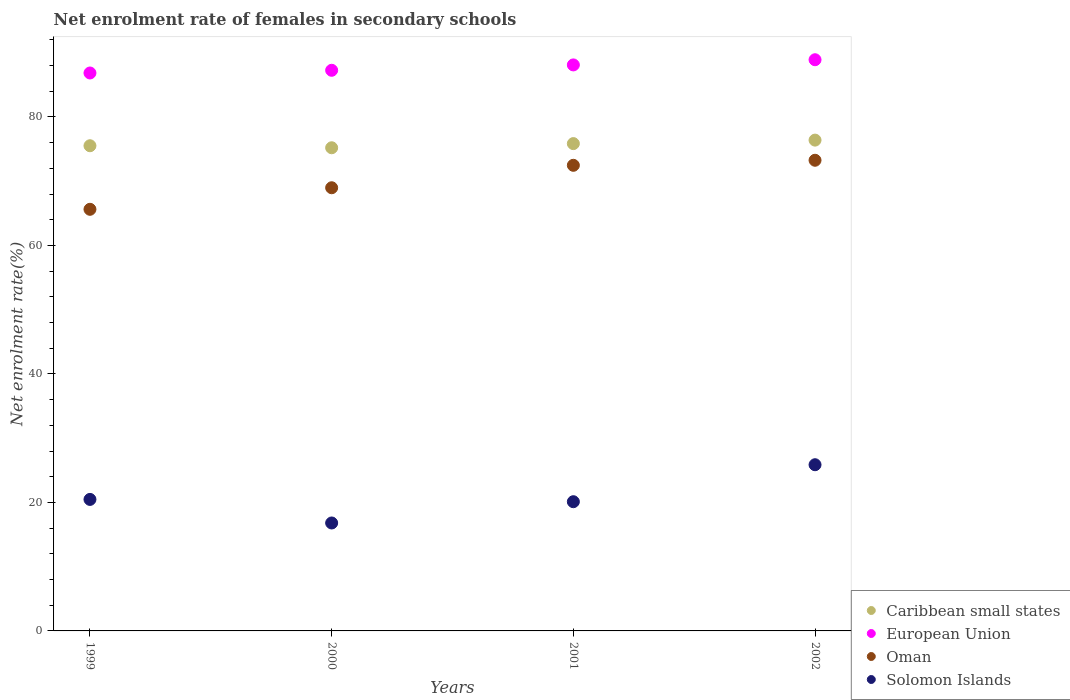How many different coloured dotlines are there?
Your response must be concise. 4. Is the number of dotlines equal to the number of legend labels?
Make the answer very short. Yes. What is the net enrolment rate of females in secondary schools in Oman in 2000?
Your response must be concise. 68.98. Across all years, what is the maximum net enrolment rate of females in secondary schools in European Union?
Make the answer very short. 88.91. Across all years, what is the minimum net enrolment rate of females in secondary schools in European Union?
Make the answer very short. 86.85. In which year was the net enrolment rate of females in secondary schools in Solomon Islands maximum?
Give a very brief answer. 2002. What is the total net enrolment rate of females in secondary schools in Oman in the graph?
Make the answer very short. 280.35. What is the difference between the net enrolment rate of females in secondary schools in Caribbean small states in 2000 and that in 2002?
Give a very brief answer. -1.19. What is the difference between the net enrolment rate of females in secondary schools in Caribbean small states in 1999 and the net enrolment rate of females in secondary schools in European Union in 2001?
Offer a very short reply. -12.58. What is the average net enrolment rate of females in secondary schools in European Union per year?
Your response must be concise. 87.78. In the year 2000, what is the difference between the net enrolment rate of females in secondary schools in European Union and net enrolment rate of females in secondary schools in Oman?
Offer a terse response. 18.29. What is the ratio of the net enrolment rate of females in secondary schools in Solomon Islands in 1999 to that in 2000?
Make the answer very short. 1.22. Is the net enrolment rate of females in secondary schools in European Union in 2000 less than that in 2001?
Make the answer very short. Yes. What is the difference between the highest and the second highest net enrolment rate of females in secondary schools in Solomon Islands?
Your response must be concise. 5.4. What is the difference between the highest and the lowest net enrolment rate of females in secondary schools in Solomon Islands?
Provide a short and direct response. 9.07. Is it the case that in every year, the sum of the net enrolment rate of females in secondary schools in Caribbean small states and net enrolment rate of females in secondary schools in European Union  is greater than the sum of net enrolment rate of females in secondary schools in Solomon Islands and net enrolment rate of females in secondary schools in Oman?
Your response must be concise. Yes. Is the net enrolment rate of females in secondary schools in Caribbean small states strictly greater than the net enrolment rate of females in secondary schools in Solomon Islands over the years?
Your answer should be compact. Yes. How many dotlines are there?
Your response must be concise. 4. How many years are there in the graph?
Keep it short and to the point. 4. What is the difference between two consecutive major ticks on the Y-axis?
Your answer should be very brief. 20. What is the title of the graph?
Give a very brief answer. Net enrolment rate of females in secondary schools. Does "Liechtenstein" appear as one of the legend labels in the graph?
Your answer should be very brief. No. What is the label or title of the X-axis?
Keep it short and to the point. Years. What is the label or title of the Y-axis?
Provide a succinct answer. Net enrolment rate(%). What is the Net enrolment rate(%) in Caribbean small states in 1999?
Your answer should be compact. 75.52. What is the Net enrolment rate(%) of European Union in 1999?
Offer a terse response. 86.85. What is the Net enrolment rate(%) of Oman in 1999?
Ensure brevity in your answer.  65.63. What is the Net enrolment rate(%) in Solomon Islands in 1999?
Your response must be concise. 20.47. What is the Net enrolment rate(%) in Caribbean small states in 2000?
Your response must be concise. 75.21. What is the Net enrolment rate(%) of European Union in 2000?
Give a very brief answer. 87.27. What is the Net enrolment rate(%) of Oman in 2000?
Your answer should be very brief. 68.98. What is the Net enrolment rate(%) in Solomon Islands in 2000?
Offer a terse response. 16.8. What is the Net enrolment rate(%) in Caribbean small states in 2001?
Provide a succinct answer. 75.85. What is the Net enrolment rate(%) in European Union in 2001?
Keep it short and to the point. 88.1. What is the Net enrolment rate(%) in Oman in 2001?
Offer a terse response. 72.48. What is the Net enrolment rate(%) in Solomon Islands in 2001?
Offer a terse response. 20.11. What is the Net enrolment rate(%) in Caribbean small states in 2002?
Your answer should be compact. 76.4. What is the Net enrolment rate(%) of European Union in 2002?
Your answer should be compact. 88.91. What is the Net enrolment rate(%) in Oman in 2002?
Your answer should be very brief. 73.26. What is the Net enrolment rate(%) in Solomon Islands in 2002?
Your answer should be very brief. 25.87. Across all years, what is the maximum Net enrolment rate(%) of Caribbean small states?
Your response must be concise. 76.4. Across all years, what is the maximum Net enrolment rate(%) of European Union?
Make the answer very short. 88.91. Across all years, what is the maximum Net enrolment rate(%) in Oman?
Provide a short and direct response. 73.26. Across all years, what is the maximum Net enrolment rate(%) of Solomon Islands?
Your answer should be very brief. 25.87. Across all years, what is the minimum Net enrolment rate(%) in Caribbean small states?
Provide a succinct answer. 75.21. Across all years, what is the minimum Net enrolment rate(%) in European Union?
Provide a succinct answer. 86.85. Across all years, what is the minimum Net enrolment rate(%) in Oman?
Provide a succinct answer. 65.63. Across all years, what is the minimum Net enrolment rate(%) in Solomon Islands?
Your answer should be compact. 16.8. What is the total Net enrolment rate(%) of Caribbean small states in the graph?
Provide a succinct answer. 302.98. What is the total Net enrolment rate(%) in European Union in the graph?
Ensure brevity in your answer.  351.13. What is the total Net enrolment rate(%) of Oman in the graph?
Your answer should be compact. 280.35. What is the total Net enrolment rate(%) of Solomon Islands in the graph?
Provide a succinct answer. 83.25. What is the difference between the Net enrolment rate(%) in Caribbean small states in 1999 and that in 2000?
Your answer should be compact. 0.32. What is the difference between the Net enrolment rate(%) of European Union in 1999 and that in 2000?
Your response must be concise. -0.42. What is the difference between the Net enrolment rate(%) of Oman in 1999 and that in 2000?
Provide a succinct answer. -3.35. What is the difference between the Net enrolment rate(%) in Solomon Islands in 1999 and that in 2000?
Provide a short and direct response. 3.67. What is the difference between the Net enrolment rate(%) of Caribbean small states in 1999 and that in 2001?
Make the answer very short. -0.33. What is the difference between the Net enrolment rate(%) of European Union in 1999 and that in 2001?
Ensure brevity in your answer.  -1.26. What is the difference between the Net enrolment rate(%) in Oman in 1999 and that in 2001?
Give a very brief answer. -6.85. What is the difference between the Net enrolment rate(%) in Solomon Islands in 1999 and that in 2001?
Your answer should be very brief. 0.36. What is the difference between the Net enrolment rate(%) in Caribbean small states in 1999 and that in 2002?
Make the answer very short. -0.87. What is the difference between the Net enrolment rate(%) in European Union in 1999 and that in 2002?
Give a very brief answer. -2.06. What is the difference between the Net enrolment rate(%) in Oman in 1999 and that in 2002?
Offer a terse response. -7.64. What is the difference between the Net enrolment rate(%) of Solomon Islands in 1999 and that in 2002?
Provide a succinct answer. -5.4. What is the difference between the Net enrolment rate(%) of Caribbean small states in 2000 and that in 2001?
Keep it short and to the point. -0.65. What is the difference between the Net enrolment rate(%) of European Union in 2000 and that in 2001?
Provide a succinct answer. -0.84. What is the difference between the Net enrolment rate(%) of Oman in 2000 and that in 2001?
Your answer should be compact. -3.49. What is the difference between the Net enrolment rate(%) in Solomon Islands in 2000 and that in 2001?
Keep it short and to the point. -3.31. What is the difference between the Net enrolment rate(%) in Caribbean small states in 2000 and that in 2002?
Ensure brevity in your answer.  -1.19. What is the difference between the Net enrolment rate(%) in European Union in 2000 and that in 2002?
Provide a short and direct response. -1.64. What is the difference between the Net enrolment rate(%) of Oman in 2000 and that in 2002?
Keep it short and to the point. -4.28. What is the difference between the Net enrolment rate(%) of Solomon Islands in 2000 and that in 2002?
Make the answer very short. -9.07. What is the difference between the Net enrolment rate(%) of Caribbean small states in 2001 and that in 2002?
Keep it short and to the point. -0.54. What is the difference between the Net enrolment rate(%) of European Union in 2001 and that in 2002?
Give a very brief answer. -0.81. What is the difference between the Net enrolment rate(%) in Oman in 2001 and that in 2002?
Your answer should be compact. -0.79. What is the difference between the Net enrolment rate(%) in Solomon Islands in 2001 and that in 2002?
Your answer should be very brief. -5.76. What is the difference between the Net enrolment rate(%) of Caribbean small states in 1999 and the Net enrolment rate(%) of European Union in 2000?
Provide a short and direct response. -11.74. What is the difference between the Net enrolment rate(%) of Caribbean small states in 1999 and the Net enrolment rate(%) of Oman in 2000?
Give a very brief answer. 6.54. What is the difference between the Net enrolment rate(%) of Caribbean small states in 1999 and the Net enrolment rate(%) of Solomon Islands in 2000?
Offer a very short reply. 58.72. What is the difference between the Net enrolment rate(%) in European Union in 1999 and the Net enrolment rate(%) in Oman in 2000?
Offer a very short reply. 17.87. What is the difference between the Net enrolment rate(%) of European Union in 1999 and the Net enrolment rate(%) of Solomon Islands in 2000?
Ensure brevity in your answer.  70.04. What is the difference between the Net enrolment rate(%) of Oman in 1999 and the Net enrolment rate(%) of Solomon Islands in 2000?
Keep it short and to the point. 48.83. What is the difference between the Net enrolment rate(%) of Caribbean small states in 1999 and the Net enrolment rate(%) of European Union in 2001?
Your response must be concise. -12.58. What is the difference between the Net enrolment rate(%) of Caribbean small states in 1999 and the Net enrolment rate(%) of Oman in 2001?
Keep it short and to the point. 3.05. What is the difference between the Net enrolment rate(%) in Caribbean small states in 1999 and the Net enrolment rate(%) in Solomon Islands in 2001?
Make the answer very short. 55.41. What is the difference between the Net enrolment rate(%) in European Union in 1999 and the Net enrolment rate(%) in Oman in 2001?
Keep it short and to the point. 14.37. What is the difference between the Net enrolment rate(%) in European Union in 1999 and the Net enrolment rate(%) in Solomon Islands in 2001?
Give a very brief answer. 66.73. What is the difference between the Net enrolment rate(%) of Oman in 1999 and the Net enrolment rate(%) of Solomon Islands in 2001?
Ensure brevity in your answer.  45.51. What is the difference between the Net enrolment rate(%) in Caribbean small states in 1999 and the Net enrolment rate(%) in European Union in 2002?
Your answer should be very brief. -13.39. What is the difference between the Net enrolment rate(%) of Caribbean small states in 1999 and the Net enrolment rate(%) of Oman in 2002?
Ensure brevity in your answer.  2.26. What is the difference between the Net enrolment rate(%) in Caribbean small states in 1999 and the Net enrolment rate(%) in Solomon Islands in 2002?
Provide a succinct answer. 49.65. What is the difference between the Net enrolment rate(%) of European Union in 1999 and the Net enrolment rate(%) of Oman in 2002?
Your response must be concise. 13.58. What is the difference between the Net enrolment rate(%) in European Union in 1999 and the Net enrolment rate(%) in Solomon Islands in 2002?
Keep it short and to the point. 60.98. What is the difference between the Net enrolment rate(%) in Oman in 1999 and the Net enrolment rate(%) in Solomon Islands in 2002?
Your answer should be very brief. 39.76. What is the difference between the Net enrolment rate(%) of Caribbean small states in 2000 and the Net enrolment rate(%) of European Union in 2001?
Offer a very short reply. -12.9. What is the difference between the Net enrolment rate(%) of Caribbean small states in 2000 and the Net enrolment rate(%) of Oman in 2001?
Your answer should be very brief. 2.73. What is the difference between the Net enrolment rate(%) in Caribbean small states in 2000 and the Net enrolment rate(%) in Solomon Islands in 2001?
Your answer should be very brief. 55.09. What is the difference between the Net enrolment rate(%) in European Union in 2000 and the Net enrolment rate(%) in Oman in 2001?
Offer a terse response. 14.79. What is the difference between the Net enrolment rate(%) in European Union in 2000 and the Net enrolment rate(%) in Solomon Islands in 2001?
Offer a terse response. 67.15. What is the difference between the Net enrolment rate(%) in Oman in 2000 and the Net enrolment rate(%) in Solomon Islands in 2001?
Provide a succinct answer. 48.87. What is the difference between the Net enrolment rate(%) of Caribbean small states in 2000 and the Net enrolment rate(%) of European Union in 2002?
Your answer should be very brief. -13.7. What is the difference between the Net enrolment rate(%) in Caribbean small states in 2000 and the Net enrolment rate(%) in Oman in 2002?
Your response must be concise. 1.94. What is the difference between the Net enrolment rate(%) in Caribbean small states in 2000 and the Net enrolment rate(%) in Solomon Islands in 2002?
Offer a very short reply. 49.34. What is the difference between the Net enrolment rate(%) in European Union in 2000 and the Net enrolment rate(%) in Oman in 2002?
Offer a terse response. 14. What is the difference between the Net enrolment rate(%) in European Union in 2000 and the Net enrolment rate(%) in Solomon Islands in 2002?
Offer a very short reply. 61.4. What is the difference between the Net enrolment rate(%) of Oman in 2000 and the Net enrolment rate(%) of Solomon Islands in 2002?
Provide a succinct answer. 43.11. What is the difference between the Net enrolment rate(%) in Caribbean small states in 2001 and the Net enrolment rate(%) in European Union in 2002?
Your response must be concise. -13.05. What is the difference between the Net enrolment rate(%) of Caribbean small states in 2001 and the Net enrolment rate(%) of Oman in 2002?
Offer a very short reply. 2.59. What is the difference between the Net enrolment rate(%) of Caribbean small states in 2001 and the Net enrolment rate(%) of Solomon Islands in 2002?
Provide a succinct answer. 49.99. What is the difference between the Net enrolment rate(%) in European Union in 2001 and the Net enrolment rate(%) in Oman in 2002?
Your answer should be compact. 14.84. What is the difference between the Net enrolment rate(%) of European Union in 2001 and the Net enrolment rate(%) of Solomon Islands in 2002?
Ensure brevity in your answer.  62.23. What is the difference between the Net enrolment rate(%) of Oman in 2001 and the Net enrolment rate(%) of Solomon Islands in 2002?
Make the answer very short. 46.61. What is the average Net enrolment rate(%) of Caribbean small states per year?
Ensure brevity in your answer.  75.75. What is the average Net enrolment rate(%) in European Union per year?
Offer a terse response. 87.78. What is the average Net enrolment rate(%) in Oman per year?
Your answer should be compact. 70.09. What is the average Net enrolment rate(%) in Solomon Islands per year?
Provide a short and direct response. 20.81. In the year 1999, what is the difference between the Net enrolment rate(%) in Caribbean small states and Net enrolment rate(%) in European Union?
Provide a short and direct response. -11.32. In the year 1999, what is the difference between the Net enrolment rate(%) in Caribbean small states and Net enrolment rate(%) in Oman?
Provide a short and direct response. 9.9. In the year 1999, what is the difference between the Net enrolment rate(%) of Caribbean small states and Net enrolment rate(%) of Solomon Islands?
Provide a succinct answer. 55.05. In the year 1999, what is the difference between the Net enrolment rate(%) of European Union and Net enrolment rate(%) of Oman?
Offer a terse response. 21.22. In the year 1999, what is the difference between the Net enrolment rate(%) of European Union and Net enrolment rate(%) of Solomon Islands?
Your answer should be compact. 66.38. In the year 1999, what is the difference between the Net enrolment rate(%) in Oman and Net enrolment rate(%) in Solomon Islands?
Give a very brief answer. 45.16. In the year 2000, what is the difference between the Net enrolment rate(%) in Caribbean small states and Net enrolment rate(%) in European Union?
Offer a very short reply. -12.06. In the year 2000, what is the difference between the Net enrolment rate(%) in Caribbean small states and Net enrolment rate(%) in Oman?
Offer a very short reply. 6.22. In the year 2000, what is the difference between the Net enrolment rate(%) in Caribbean small states and Net enrolment rate(%) in Solomon Islands?
Keep it short and to the point. 58.4. In the year 2000, what is the difference between the Net enrolment rate(%) of European Union and Net enrolment rate(%) of Oman?
Provide a short and direct response. 18.29. In the year 2000, what is the difference between the Net enrolment rate(%) of European Union and Net enrolment rate(%) of Solomon Islands?
Keep it short and to the point. 70.46. In the year 2000, what is the difference between the Net enrolment rate(%) in Oman and Net enrolment rate(%) in Solomon Islands?
Give a very brief answer. 52.18. In the year 2001, what is the difference between the Net enrolment rate(%) in Caribbean small states and Net enrolment rate(%) in European Union?
Your answer should be compact. -12.25. In the year 2001, what is the difference between the Net enrolment rate(%) of Caribbean small states and Net enrolment rate(%) of Oman?
Your response must be concise. 3.38. In the year 2001, what is the difference between the Net enrolment rate(%) in Caribbean small states and Net enrolment rate(%) in Solomon Islands?
Keep it short and to the point. 55.74. In the year 2001, what is the difference between the Net enrolment rate(%) in European Union and Net enrolment rate(%) in Oman?
Offer a very short reply. 15.63. In the year 2001, what is the difference between the Net enrolment rate(%) in European Union and Net enrolment rate(%) in Solomon Islands?
Provide a short and direct response. 67.99. In the year 2001, what is the difference between the Net enrolment rate(%) in Oman and Net enrolment rate(%) in Solomon Islands?
Offer a terse response. 52.36. In the year 2002, what is the difference between the Net enrolment rate(%) in Caribbean small states and Net enrolment rate(%) in European Union?
Offer a terse response. -12.51. In the year 2002, what is the difference between the Net enrolment rate(%) of Caribbean small states and Net enrolment rate(%) of Oman?
Offer a very short reply. 3.13. In the year 2002, what is the difference between the Net enrolment rate(%) of Caribbean small states and Net enrolment rate(%) of Solomon Islands?
Your response must be concise. 50.53. In the year 2002, what is the difference between the Net enrolment rate(%) in European Union and Net enrolment rate(%) in Oman?
Provide a short and direct response. 15.65. In the year 2002, what is the difference between the Net enrolment rate(%) in European Union and Net enrolment rate(%) in Solomon Islands?
Make the answer very short. 63.04. In the year 2002, what is the difference between the Net enrolment rate(%) of Oman and Net enrolment rate(%) of Solomon Islands?
Make the answer very short. 47.39. What is the ratio of the Net enrolment rate(%) in Caribbean small states in 1999 to that in 2000?
Ensure brevity in your answer.  1. What is the ratio of the Net enrolment rate(%) in Oman in 1999 to that in 2000?
Your response must be concise. 0.95. What is the ratio of the Net enrolment rate(%) in Solomon Islands in 1999 to that in 2000?
Give a very brief answer. 1.22. What is the ratio of the Net enrolment rate(%) in European Union in 1999 to that in 2001?
Provide a succinct answer. 0.99. What is the ratio of the Net enrolment rate(%) of Oman in 1999 to that in 2001?
Your answer should be very brief. 0.91. What is the ratio of the Net enrolment rate(%) of Solomon Islands in 1999 to that in 2001?
Provide a short and direct response. 1.02. What is the ratio of the Net enrolment rate(%) in Caribbean small states in 1999 to that in 2002?
Offer a very short reply. 0.99. What is the ratio of the Net enrolment rate(%) of European Union in 1999 to that in 2002?
Your answer should be compact. 0.98. What is the ratio of the Net enrolment rate(%) of Oman in 1999 to that in 2002?
Your answer should be very brief. 0.9. What is the ratio of the Net enrolment rate(%) of Solomon Islands in 1999 to that in 2002?
Offer a very short reply. 0.79. What is the ratio of the Net enrolment rate(%) in Oman in 2000 to that in 2001?
Provide a succinct answer. 0.95. What is the ratio of the Net enrolment rate(%) of Solomon Islands in 2000 to that in 2001?
Ensure brevity in your answer.  0.84. What is the ratio of the Net enrolment rate(%) in Caribbean small states in 2000 to that in 2002?
Provide a succinct answer. 0.98. What is the ratio of the Net enrolment rate(%) of European Union in 2000 to that in 2002?
Give a very brief answer. 0.98. What is the ratio of the Net enrolment rate(%) of Oman in 2000 to that in 2002?
Offer a terse response. 0.94. What is the ratio of the Net enrolment rate(%) in Solomon Islands in 2000 to that in 2002?
Give a very brief answer. 0.65. What is the ratio of the Net enrolment rate(%) of Caribbean small states in 2001 to that in 2002?
Ensure brevity in your answer.  0.99. What is the ratio of the Net enrolment rate(%) in European Union in 2001 to that in 2002?
Provide a succinct answer. 0.99. What is the ratio of the Net enrolment rate(%) of Oman in 2001 to that in 2002?
Give a very brief answer. 0.99. What is the ratio of the Net enrolment rate(%) in Solomon Islands in 2001 to that in 2002?
Offer a terse response. 0.78. What is the difference between the highest and the second highest Net enrolment rate(%) in Caribbean small states?
Offer a very short reply. 0.54. What is the difference between the highest and the second highest Net enrolment rate(%) of European Union?
Make the answer very short. 0.81. What is the difference between the highest and the second highest Net enrolment rate(%) of Oman?
Your answer should be compact. 0.79. What is the difference between the highest and the second highest Net enrolment rate(%) in Solomon Islands?
Your response must be concise. 5.4. What is the difference between the highest and the lowest Net enrolment rate(%) in Caribbean small states?
Provide a short and direct response. 1.19. What is the difference between the highest and the lowest Net enrolment rate(%) in European Union?
Your answer should be compact. 2.06. What is the difference between the highest and the lowest Net enrolment rate(%) of Oman?
Offer a very short reply. 7.64. What is the difference between the highest and the lowest Net enrolment rate(%) in Solomon Islands?
Ensure brevity in your answer.  9.07. 